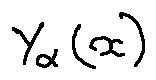Convert formula to latex. <formula><loc_0><loc_0><loc_500><loc_500>Y _ { \alpha } ( x )</formula> 